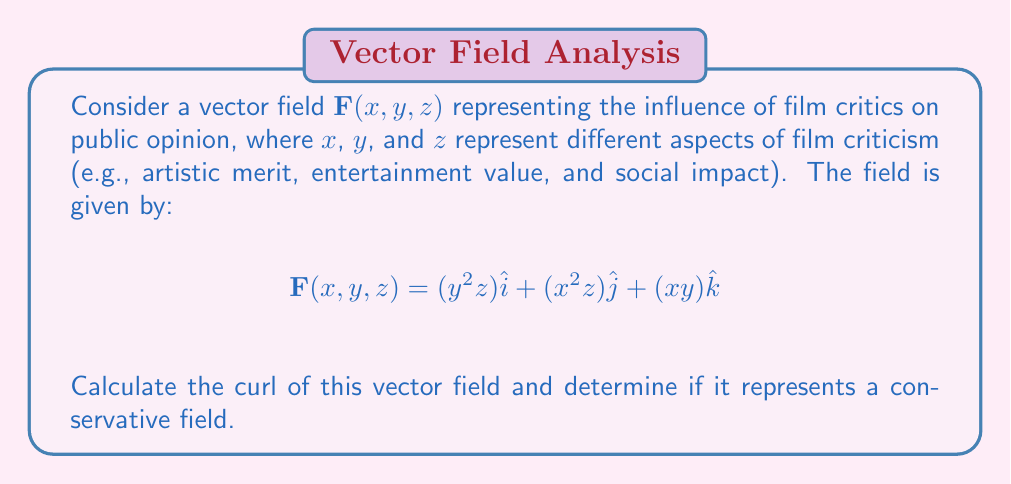Show me your answer to this math problem. To analyze the curl of the vector field and determine if it's conservative, we'll follow these steps:

1) The curl of a vector field $\mathbf{F}(x, y, z) = P\hat{i} + Q\hat{j} + R\hat{k}$ is given by:

   $$\text{curl}\,\mathbf{F} = \nabla \times \mathbf{F} = \left(\frac{\partial R}{\partial y} - \frac{\partial Q}{\partial z}\right)\hat{i} + \left(\frac{\partial P}{\partial z} - \frac{\partial R}{\partial x}\right)\hat{j} + \left(\frac{\partial Q}{\partial x} - \frac{\partial P}{\partial y}\right)\hat{k}$$

2) In our case:
   $P = y^2z$, $Q = x^2z$, $R = xy$

3) Let's calculate each component:

   $\frac{\partial R}{\partial y} - \frac{\partial Q}{\partial z} = x - x^2 = x(1-x)$

   $\frac{\partial P}{\partial z} - \frac{\partial R}{\partial x} = y^2 - y = y(y-1)$

   $\frac{\partial Q}{\partial x} - \frac{\partial P}{\partial y} = 2xz - 2yz = 2z(x-y)$

4) Therefore, the curl is:

   $$\text{curl}\,\mathbf{F} = x(1-x)\hat{i} + y(y-1)\hat{j} + 2z(x-y)\hat{k}$$

5) For a field to be conservative, its curl must be zero everywhere. Clearly, this is not the case for our vector field, as the curl is non-zero for most points $(x,y,z)$.

This non-zero curl indicates that the influence of film critics on public opinion, as represented by this vector field, is not conservative. In the context of film criticism, this suggests that the path of influence matters, and different sequences of critiques can lead to different overall impacts on public opinion.
Answer: $\text{curl}\,\mathbf{F} = x(1-x)\hat{i} + y(y-1)\hat{j} + 2z(x-y)\hat{k}$; not conservative 